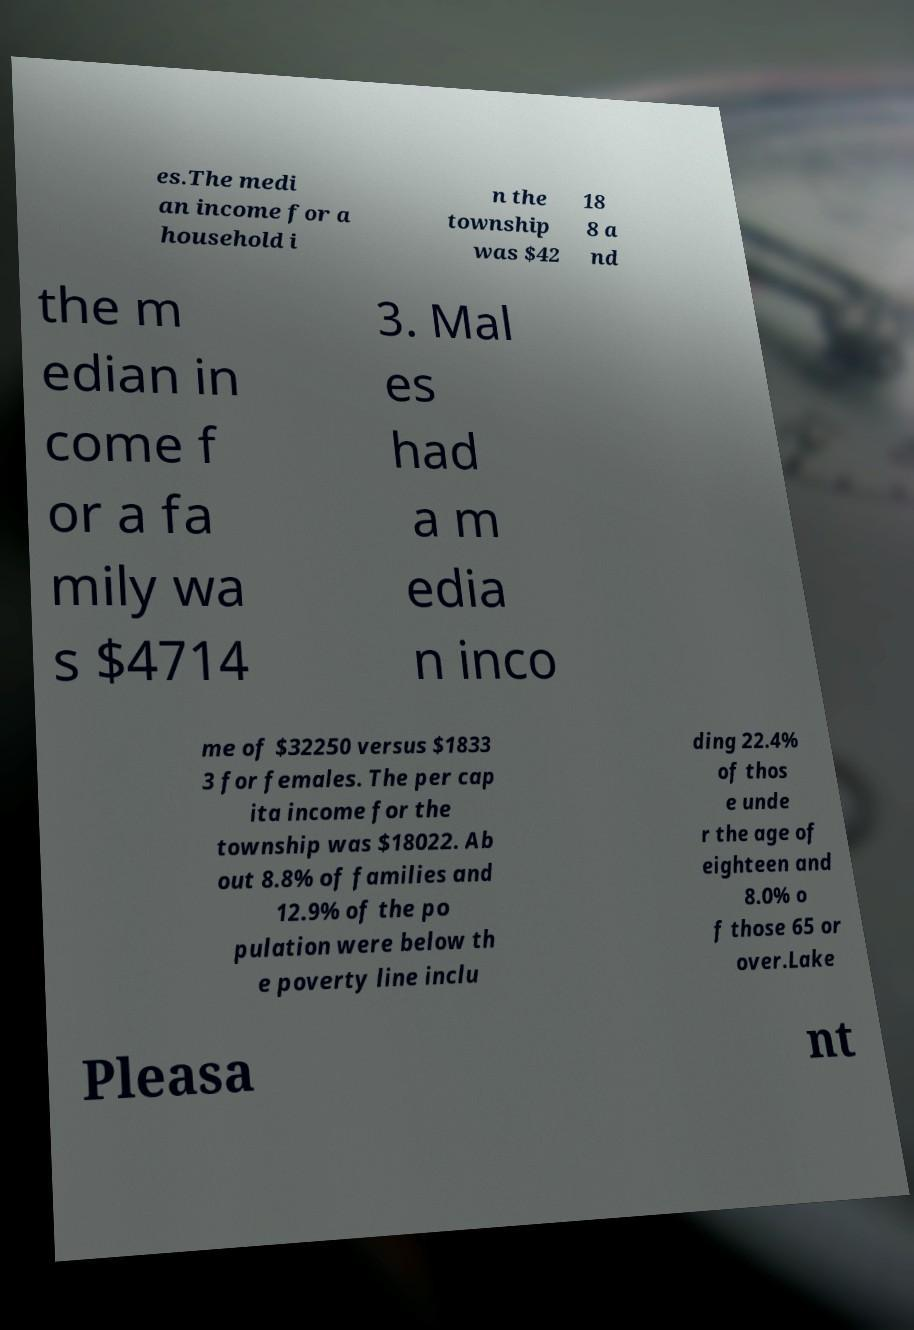There's text embedded in this image that I need extracted. Can you transcribe it verbatim? es.The medi an income for a household i n the township was $42 18 8 a nd the m edian in come f or a fa mily wa s $4714 3. Mal es had a m edia n inco me of $32250 versus $1833 3 for females. The per cap ita income for the township was $18022. Ab out 8.8% of families and 12.9% of the po pulation were below th e poverty line inclu ding 22.4% of thos e unde r the age of eighteen and 8.0% o f those 65 or over.Lake Pleasa nt 